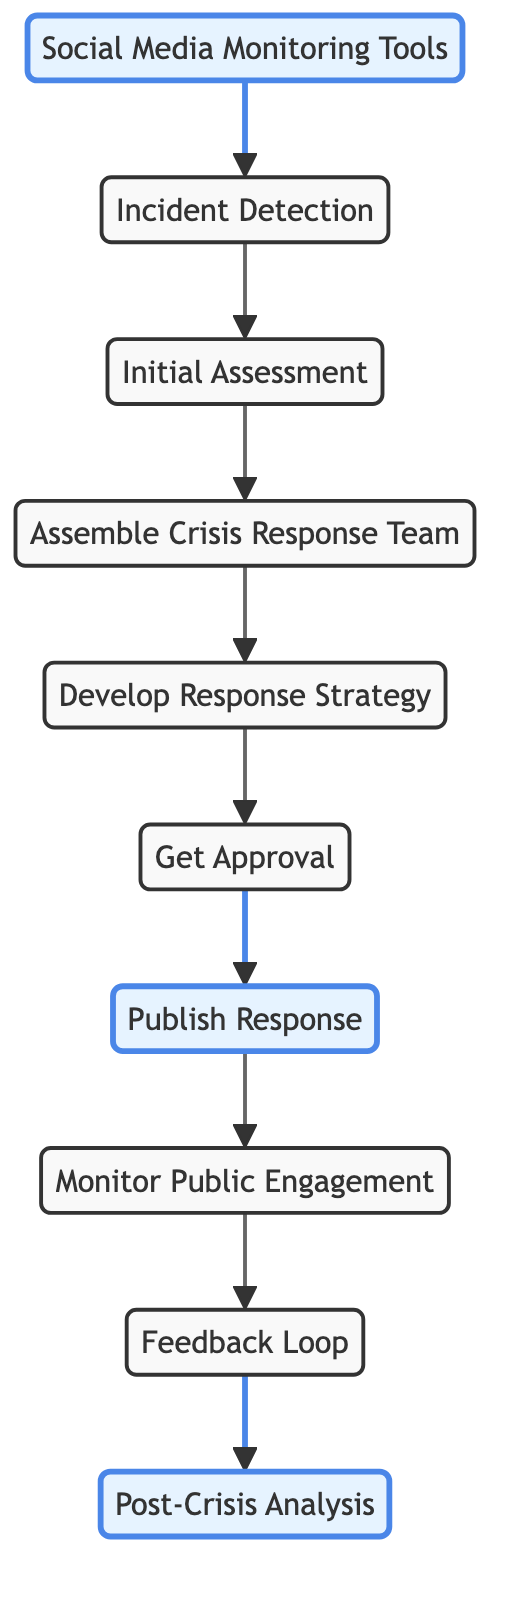What is the first step in the crisis response workflow? The first step listed in the diagram is "Social Media Monitoring Tools." This node connects to "Incident Detection," indicating it is the starting point for identifying potential crises.
Answer: Social Media Monitoring Tools How many nodes are there in the diagram? By counting the distinct elements listed in the diagram, we find there are ten nodes, each representing a specific step in the crisis response workflow.
Answer: 10 What is the last step of the crisis response workflow? The last node in the flow is "Post-Crisis Analysis," which follows the "Feedback Loop" node, summarizing the final stage of reviewing the response's effectiveness.
Answer: Post-Crisis Analysis Which node is directly connected to "Develop Response Strategy"? The diagram shows that "Get Approval" is the direct next step after "Develop Response Strategy," indicating that these two nodes have a direct connection in the workflow.
Answer: Get Approval What happens after "Publish Response"? According to the connections in the diagram, "Monitor Public Engagement" is the next step following "Publish Response," indicating the focus on tracking reactions post-publication.
Answer: Monitor Public Engagement What are the nodes that come before "Feedback Loop"? The nodes leading up to "Feedback Loop" include "Monitor Public Engagement," showing a sequence of engagement followed by the feedback mechanism.
Answer: Monitor Public Engagement Which two nodes are connected to "Incident Detection"? In the diagram, "Social Media Monitoring Tools" points to "Incident Detection" and "Initial Assessment" follows, making these two nodes directly connected to it.
Answer: Social Media Monitoring Tools and Initial Assessment How many edges are there in the diagram? The edges represent the connections between nodes, and by counting all the arrows in the diagram, we see there are nine connections (edges) in total.
Answer: 9 Which node comes directly after "Get Approval"? The diagram clearly indicates that "Publish Response" is the immediate step following "Get Approval," establishing the next action post-approval.
Answer: Publish Response What is the relationship between "Initial Assessment" and "Assemble Crisis Response Team"? The diagram shows a directed connection from "Initial Assessment" to "Assemble Crisis Response Team," implying that after assessing the incident, the team formation is the next task.
Answer: Assemble Crisis Response Team 